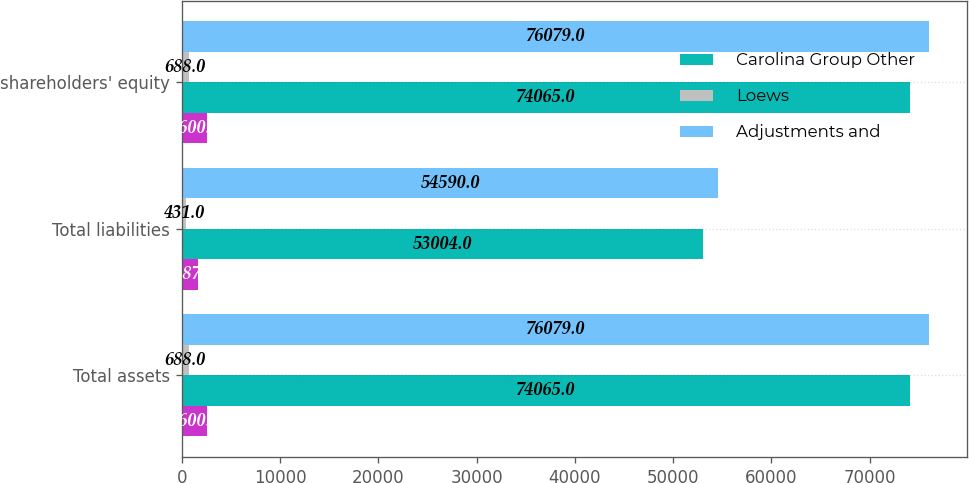Convert chart to OTSL. <chart><loc_0><loc_0><loc_500><loc_500><stacked_bar_chart><ecel><fcel>Total assets<fcel>Total liabilities<fcel>shareholders' equity<nl><fcel>nan<fcel>2600<fcel>1587<fcel>2600<nl><fcel>Carolina Group Other<fcel>74065<fcel>53004<fcel>74065<nl><fcel>Loews<fcel>688<fcel>431<fcel>688<nl><fcel>Adjustments and<fcel>76079<fcel>54590<fcel>76079<nl></chart> 